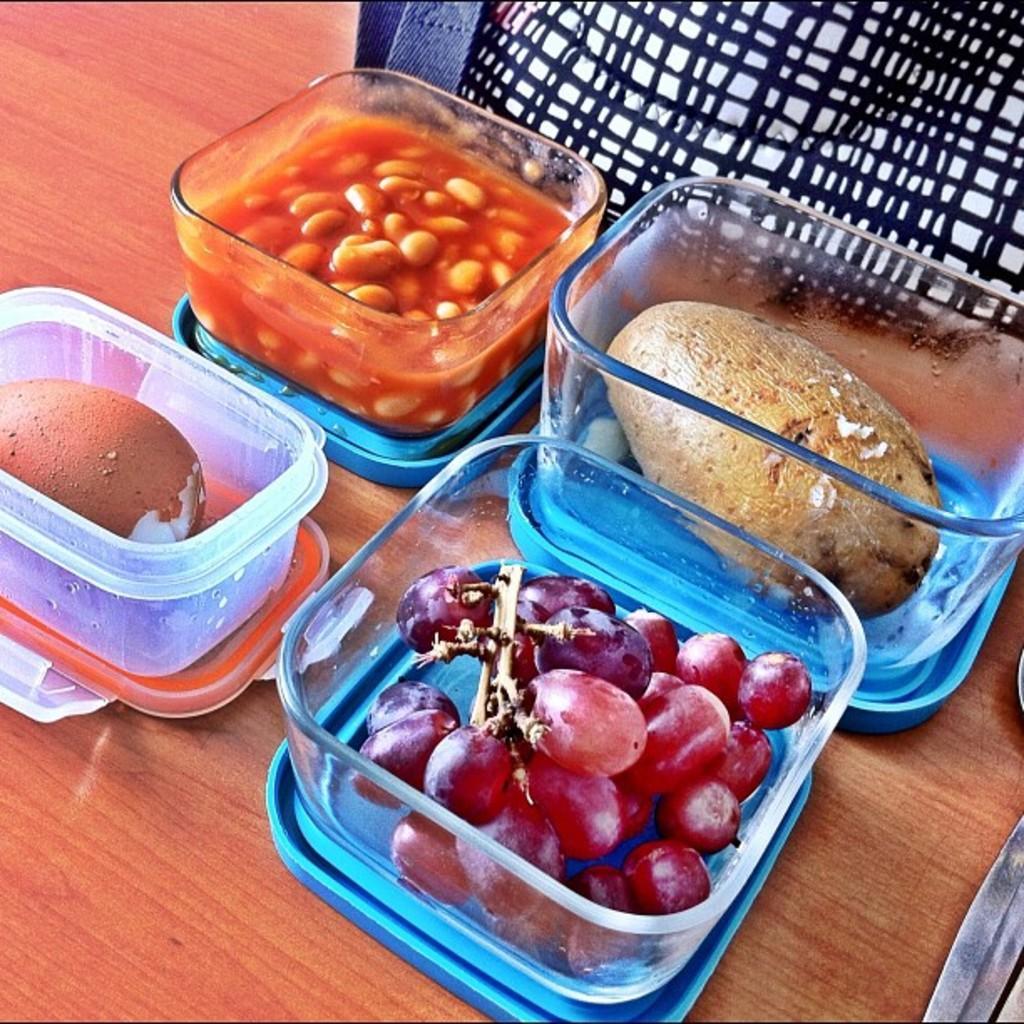How would you summarize this image in a sentence or two? This image consists of a table. On that there are 4 boxes. In that boxes there are eatables such as egg, grapes. 